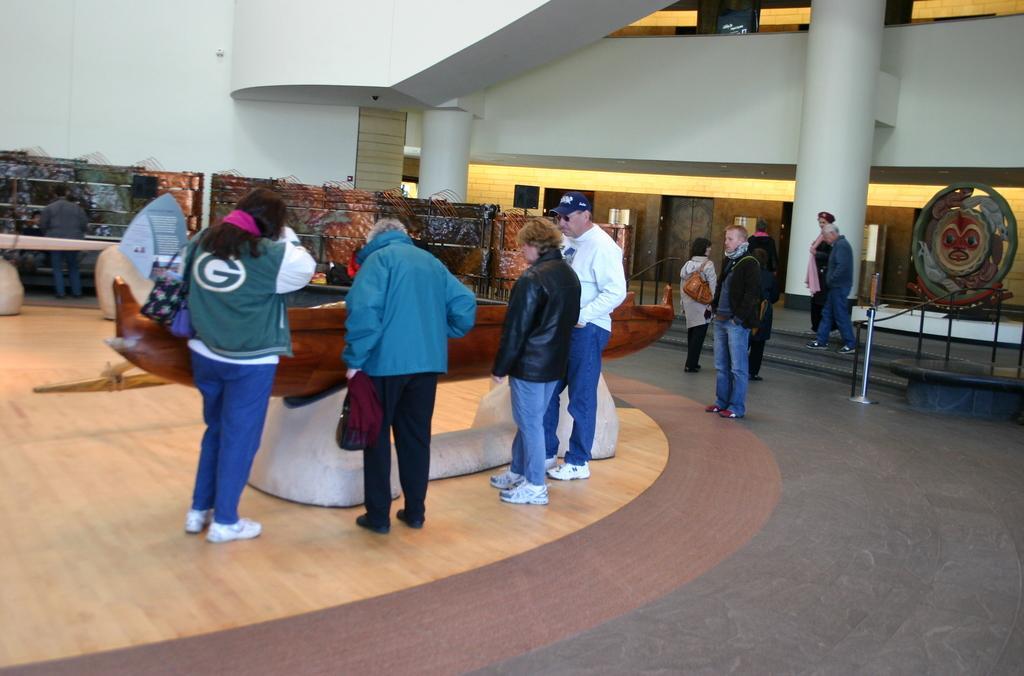How would you summarize this image in a sentence or two? This image is clicked inside the hall in which there are few people standing on the floor and looking in to the boat which is in front of them. On the right side there are pillars. At the bottom there is a wooden floor. On the right side there are few people walking on the steps. 